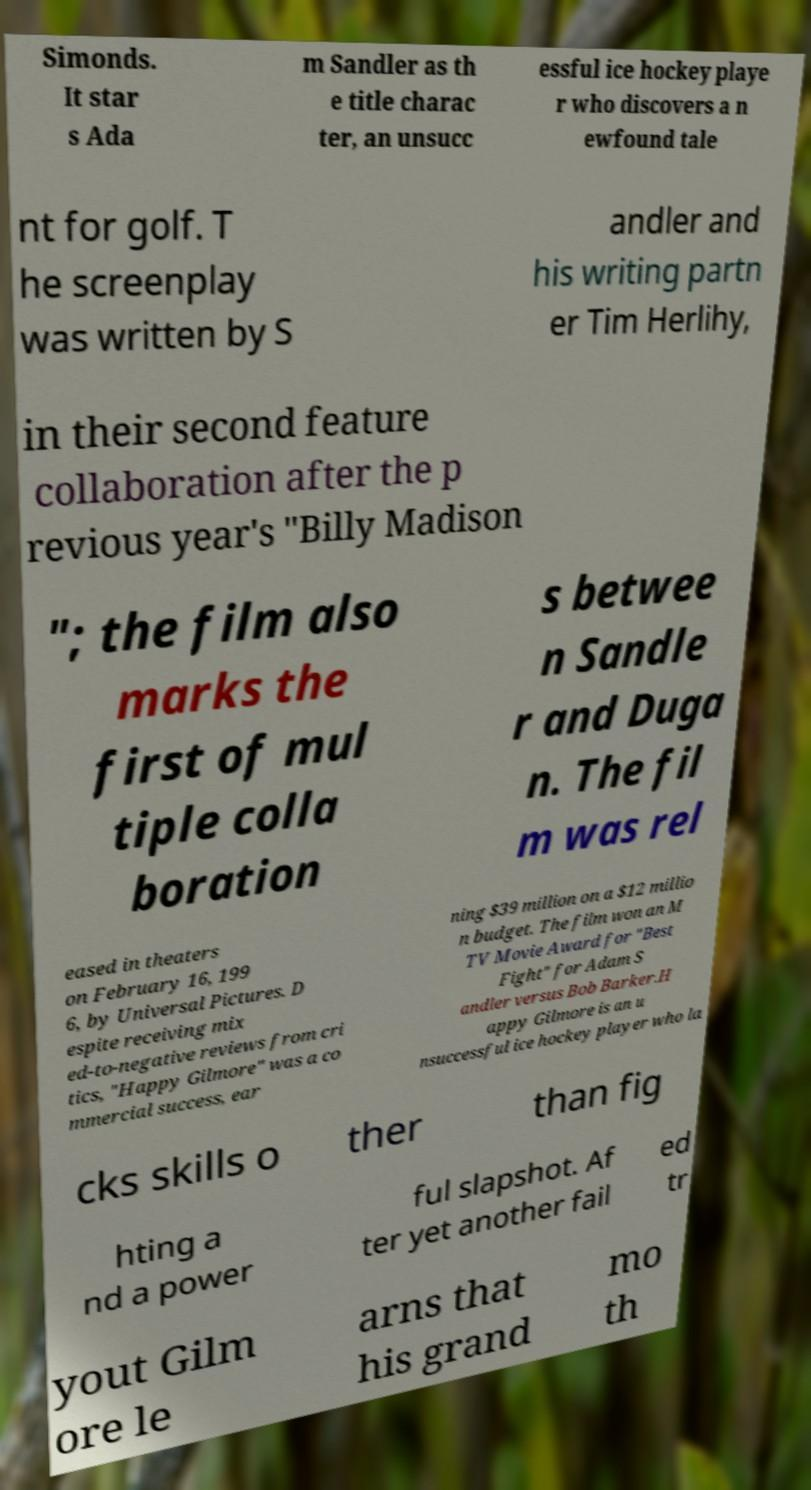Can you read and provide the text displayed in the image?This photo seems to have some interesting text. Can you extract and type it out for me? Simonds. It star s Ada m Sandler as th e title charac ter, an unsucc essful ice hockey playe r who discovers a n ewfound tale nt for golf. T he screenplay was written by S andler and his writing partn er Tim Herlihy, in their second feature collaboration after the p revious year's "Billy Madison "; the film also marks the first of mul tiple colla boration s betwee n Sandle r and Duga n. The fil m was rel eased in theaters on February 16, 199 6, by Universal Pictures. D espite receiving mix ed-to-negative reviews from cri tics, "Happy Gilmore" was a co mmercial success, ear ning $39 million on a $12 millio n budget. The film won an M TV Movie Award for "Best Fight" for Adam S andler versus Bob Barker.H appy Gilmore is an u nsuccessful ice hockey player who la cks skills o ther than fig hting a nd a power ful slapshot. Af ter yet another fail ed tr yout Gilm ore le arns that his grand mo th 